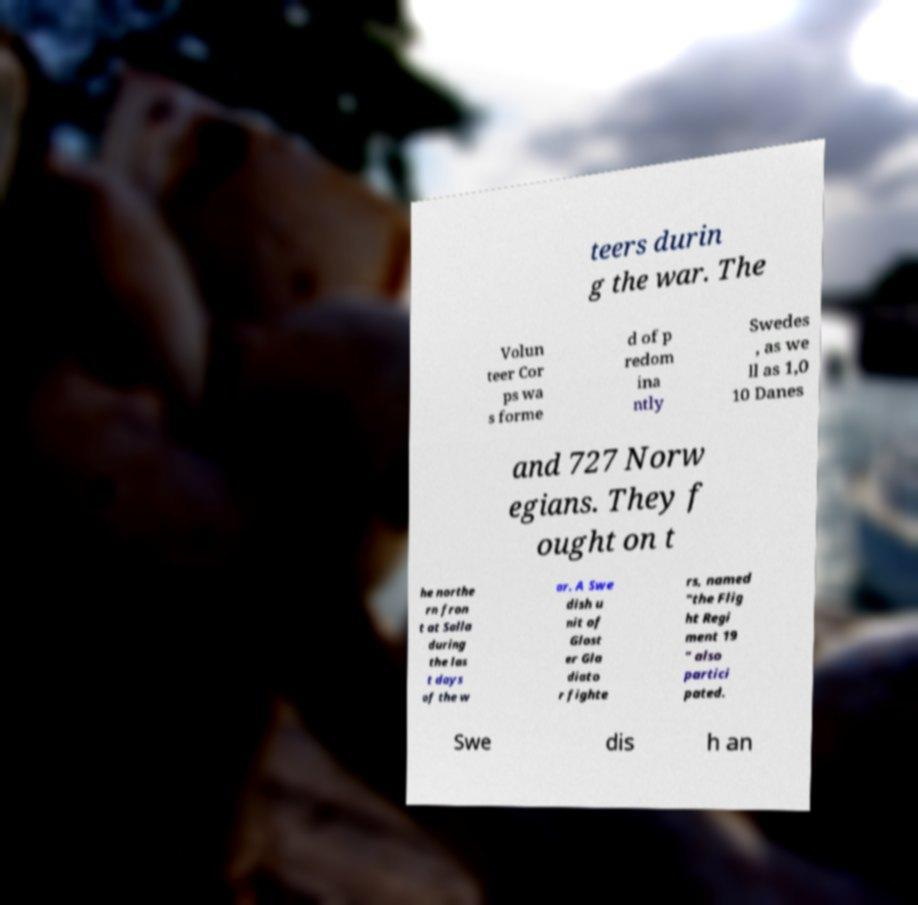Please identify and transcribe the text found in this image. teers durin g the war. The Volun teer Cor ps wa s forme d of p redom ina ntly Swedes , as we ll as 1,0 10 Danes and 727 Norw egians. They f ought on t he northe rn fron t at Salla during the las t days of the w ar. A Swe dish u nit of Glost er Gla diato r fighte rs, named "the Flig ht Regi ment 19 " also partici pated. Swe dis h an 